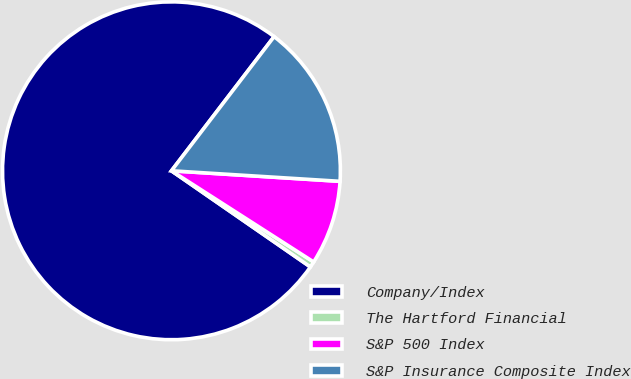Convert chart to OTSL. <chart><loc_0><loc_0><loc_500><loc_500><pie_chart><fcel>Company/Index<fcel>The Hartford Financial<fcel>S&P 500 Index<fcel>S&P Insurance Composite Index<nl><fcel>75.76%<fcel>0.56%<fcel>8.08%<fcel>15.6%<nl></chart> 